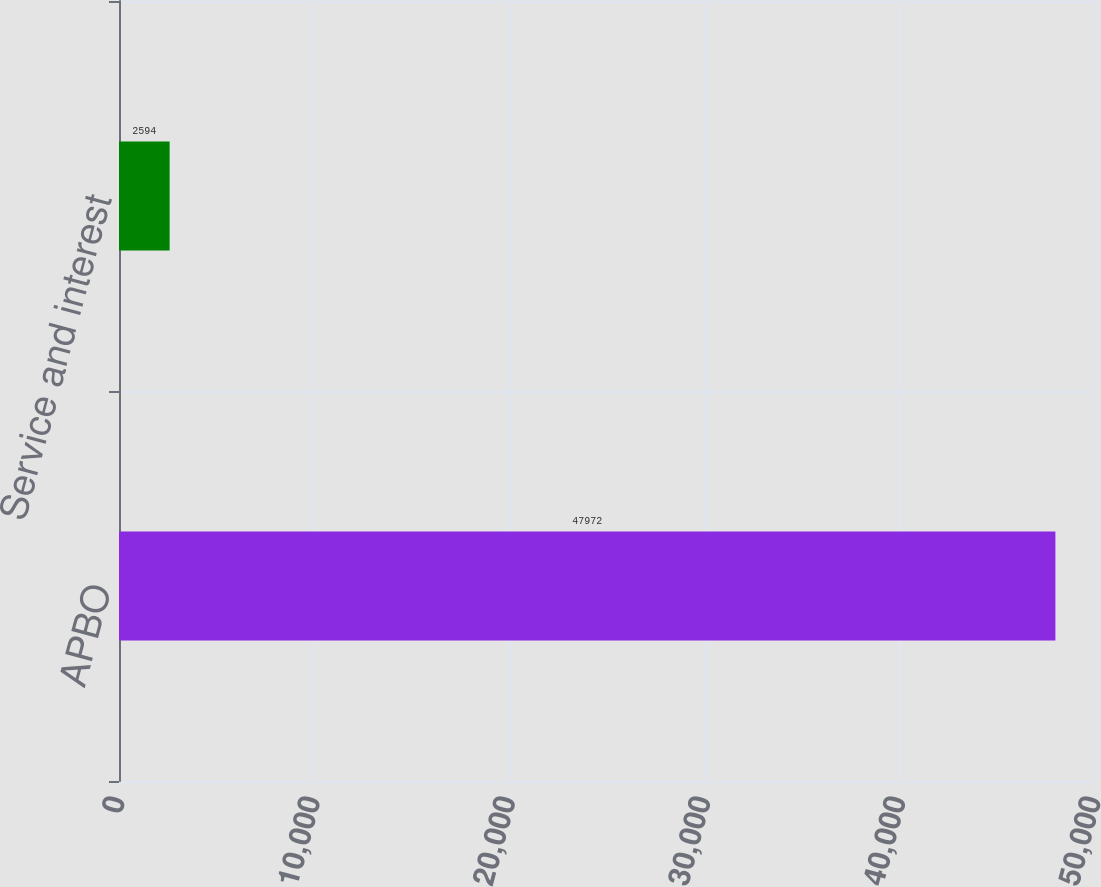Convert chart. <chart><loc_0><loc_0><loc_500><loc_500><bar_chart><fcel>APBO<fcel>Service and interest<nl><fcel>47972<fcel>2594<nl></chart> 